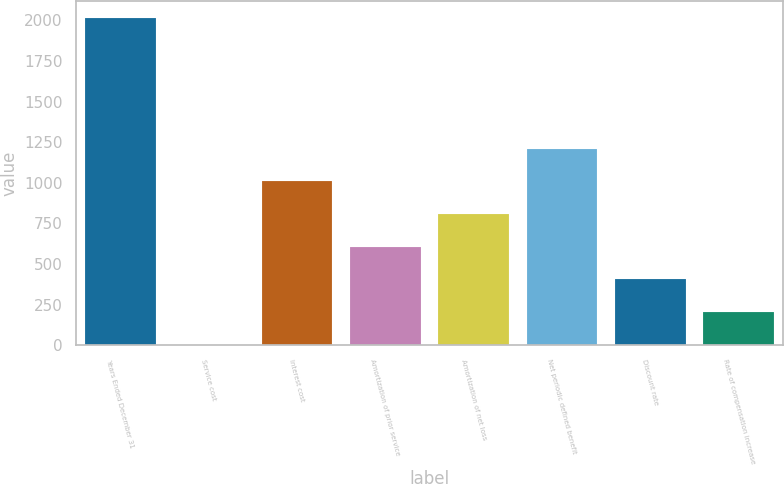<chart> <loc_0><loc_0><loc_500><loc_500><bar_chart><fcel>Years Ended December 31<fcel>Service cost<fcel>Interest cost<fcel>Amortization of prior service<fcel>Amortization of net loss<fcel>Net periodic defined benefit<fcel>Discount rate<fcel>Rate of compensation increase<nl><fcel>2016<fcel>3<fcel>1009.5<fcel>606.9<fcel>808.2<fcel>1210.8<fcel>405.6<fcel>204.3<nl></chart> 